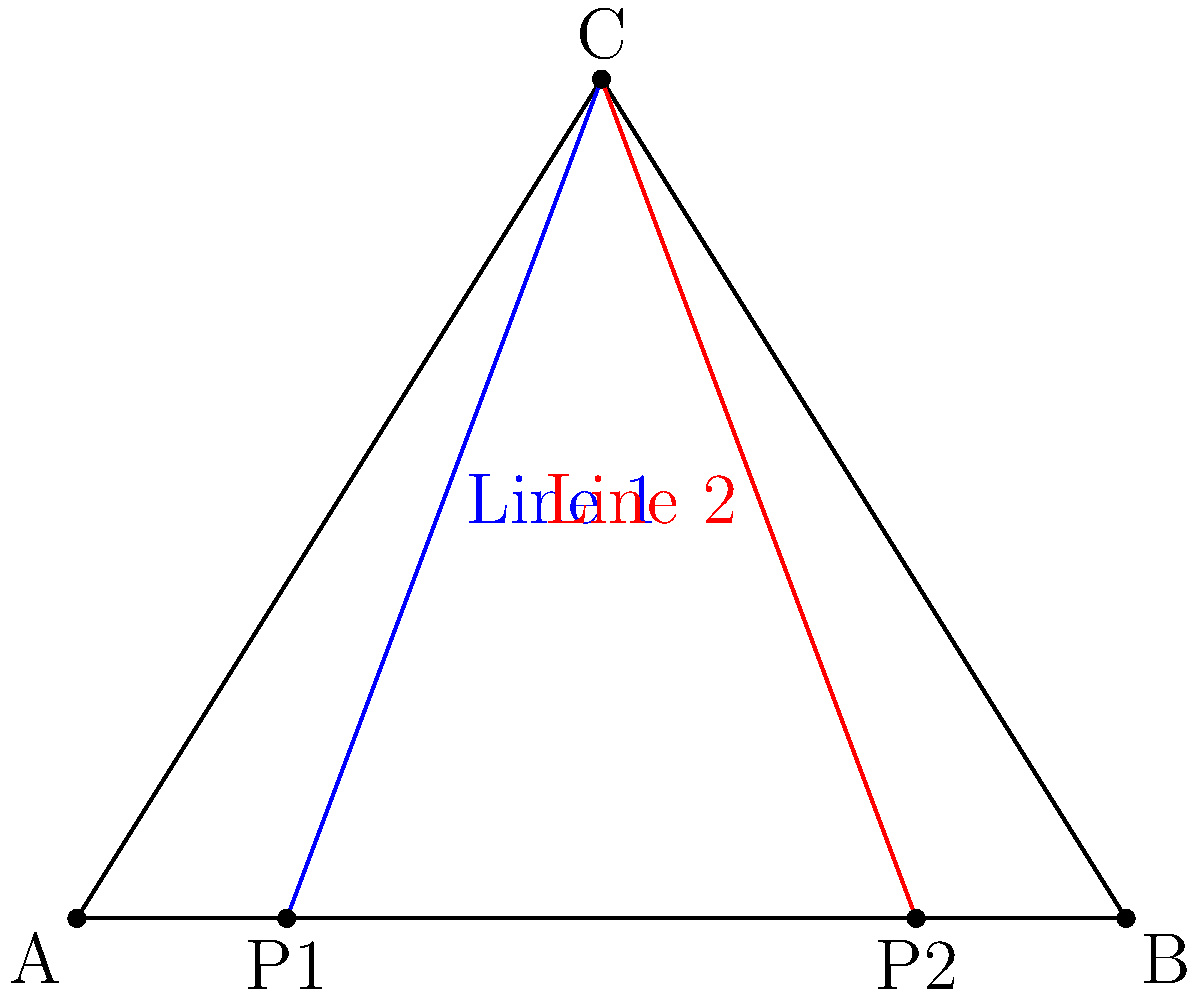In a basketball play diagram, two passing lines are represented by the equations $y = 1.6x - 3.2$ (Line 1) and $y = -1.6x + 12.8$ (Line 2). Find the coordinates of the intersection point of these two passing lines, which represents the optimal position for a player to receive both passes. Let's solve this step-by-step:

1) We have two equations:
   Line 1: $y = 1.6x - 3.2$
   Line 2: $y = -1.6x + 12.8$

2) At the intersection point, the $y$ values will be equal. So we can set the right sides of these equations equal to each other:

   $1.6x - 3.2 = -1.6x + 12.8$

3) Now, let's solve this equation for $x$:
   
   $1.6x + 1.6x = 12.8 + 3.2$
   $3.2x = 16$
   $x = 5$

4) Now that we know $x = 5$, we can substitute this back into either of our original equations to find $y$. Let's use Line 1:

   $y = 1.6(5) - 3.2$
   $y = 8 - 3.2$
   $y = 4.8$

5) Therefore, the intersection point is $(5, 4.8)$.

This point represents the optimal position for a player to receive passes from both passing angles on the court.
Answer: $(5, 4.8)$ 